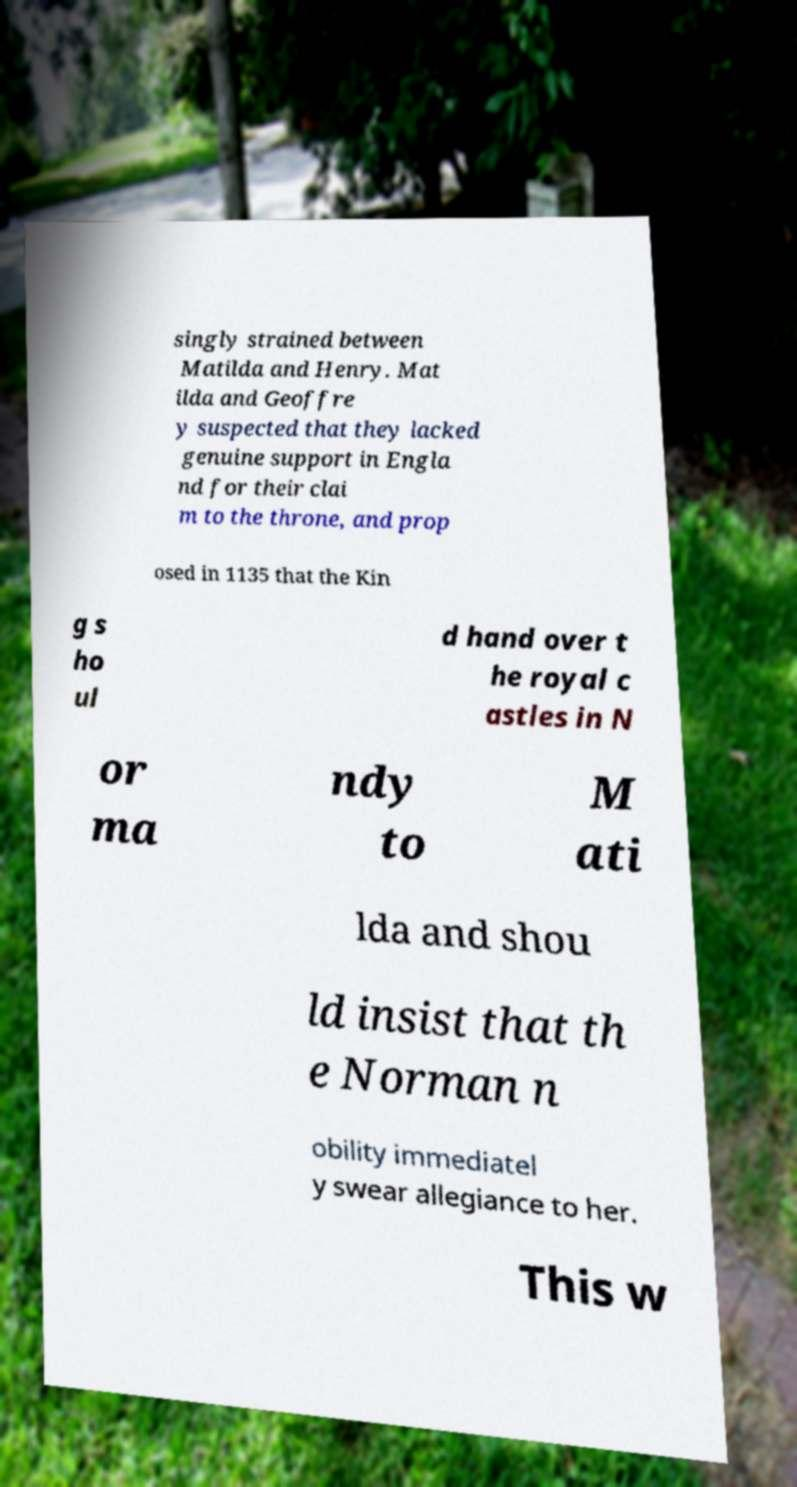Please read and relay the text visible in this image. What does it say? singly strained between Matilda and Henry. Mat ilda and Geoffre y suspected that they lacked genuine support in Engla nd for their clai m to the throne, and prop osed in 1135 that the Kin g s ho ul d hand over t he royal c astles in N or ma ndy to M ati lda and shou ld insist that th e Norman n obility immediatel y swear allegiance to her. This w 